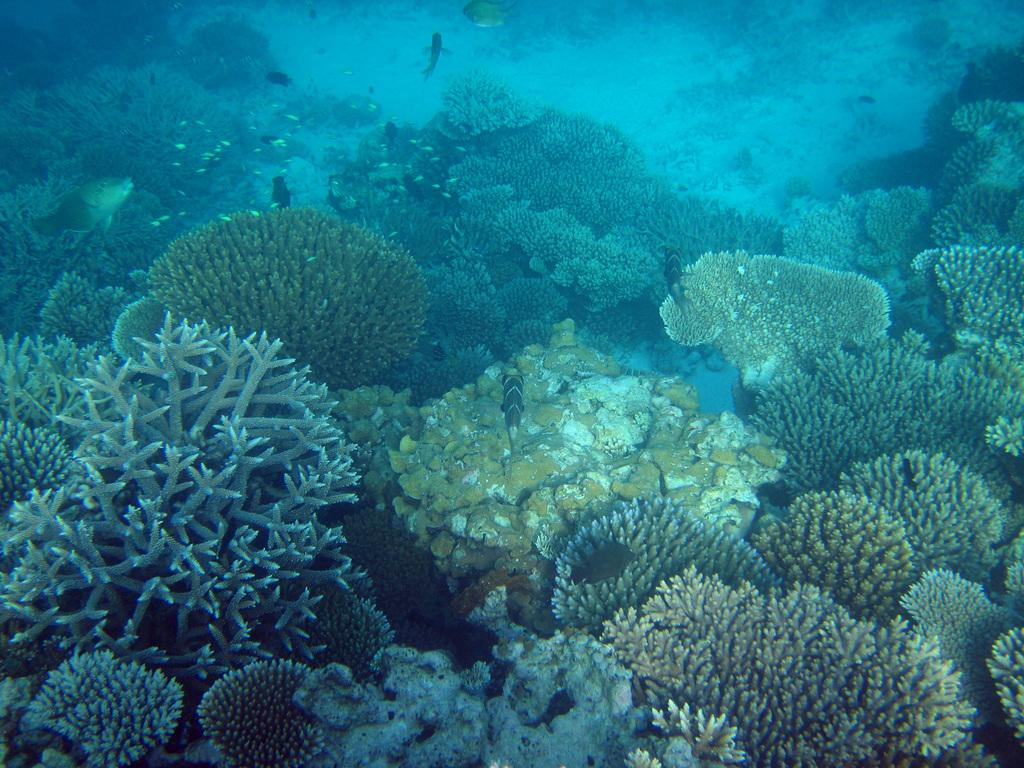What type of marine life can be seen in the image? There are corals and fishes in the image. Where is the scene of the image taking place? The scene is underwater. Can you describe the environment in the image? The environment consists of corals and fishes, which are underwater. What type of scarecrow can be seen in the image? There is no scarecrow present in the image; it is a scene of underwater marine life. 